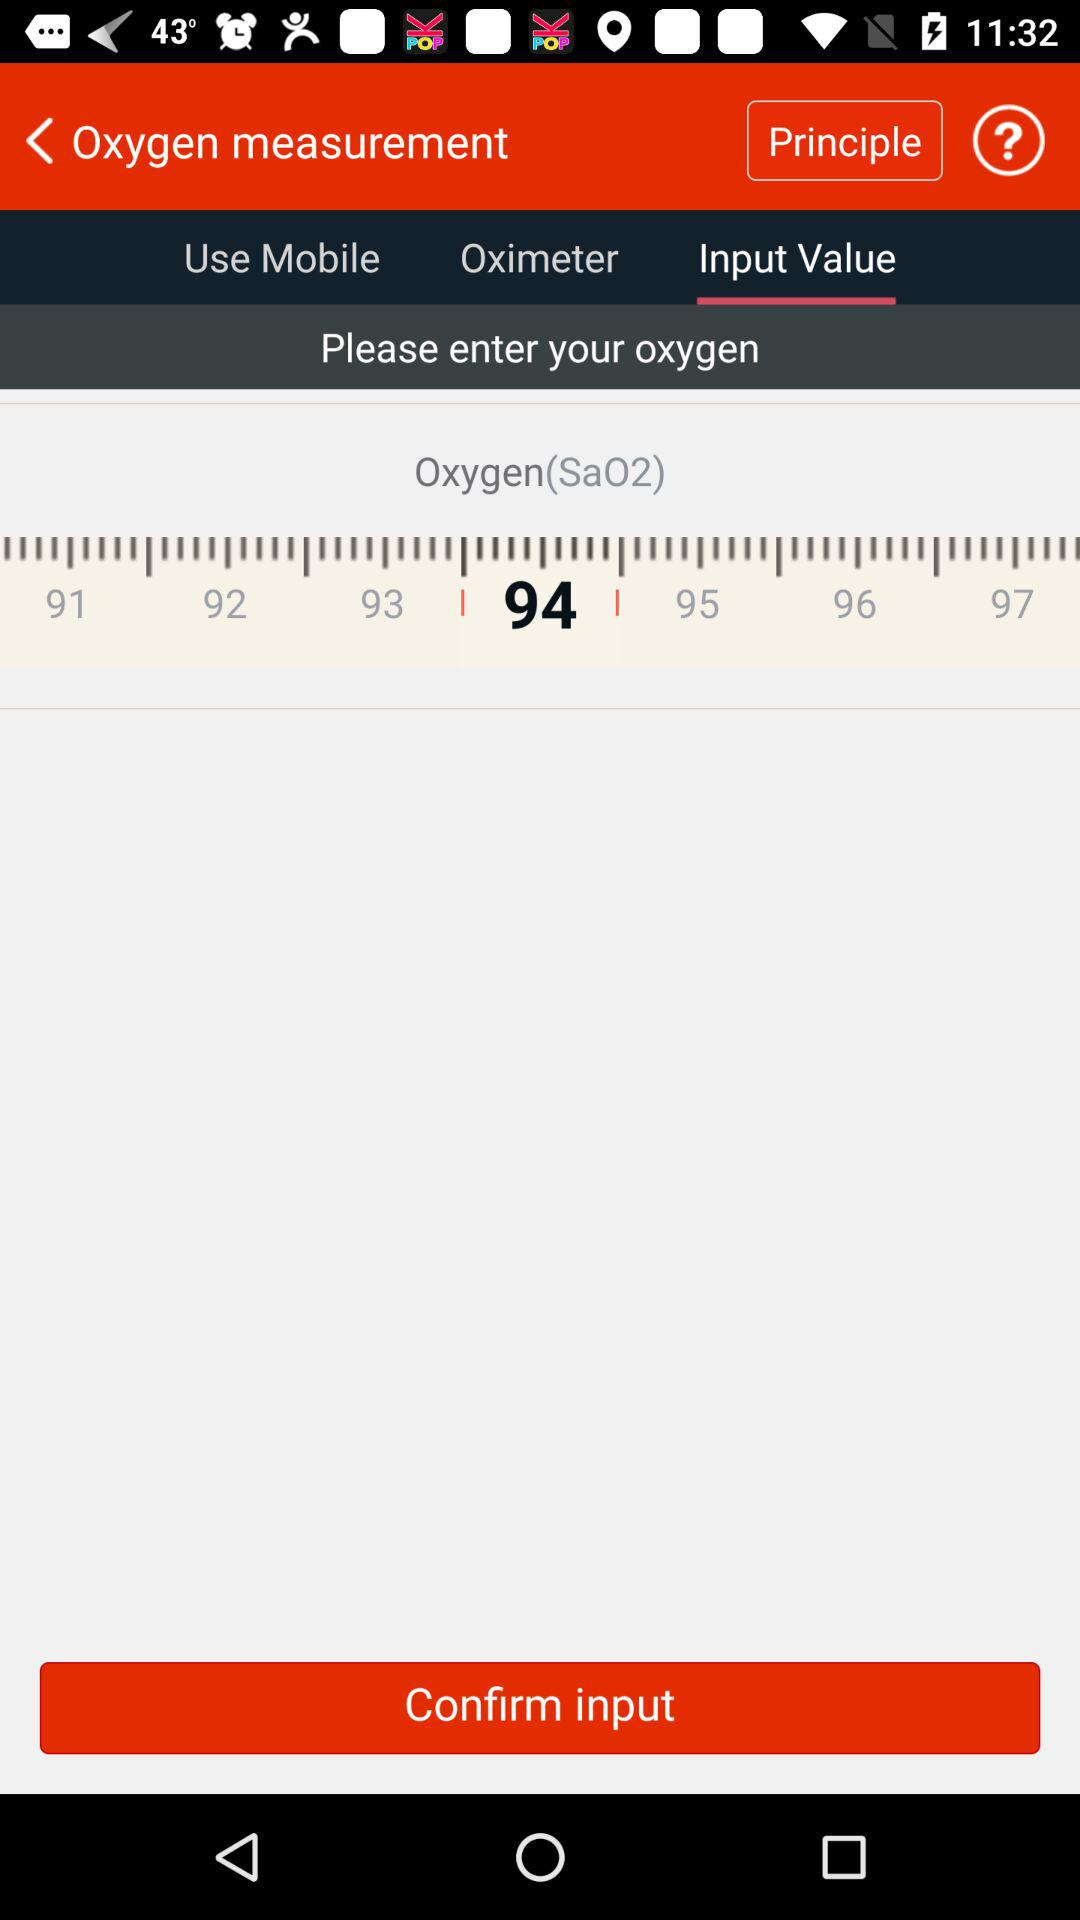What is the selected oxygen (SaO2) in "Input Value"? The selected oxygen (SaO2) in "Input Value" is 94. 